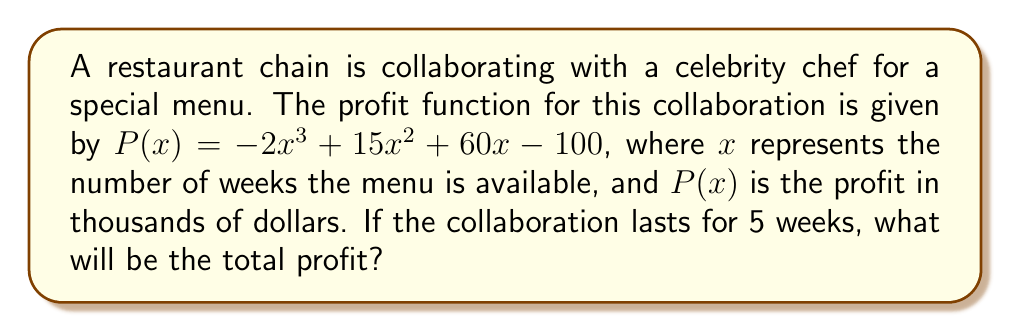Give your solution to this math problem. To find the total profit for the 5-week collaboration, we need to evaluate the profit function $P(x)$ at $x = 5$. Let's do this step by step:

1) The profit function is $P(x) = -2x^3 + 15x^2 + 60x - 100$

2) We need to calculate $P(5)$:
   $P(5) = -2(5^3) + 15(5^2) + 60(5) - 100$

3) Let's evaluate each term:
   - $-2(5^3) = -2(125) = -250$
   - $15(5^2) = 15(25) = 375$
   - $60(5) = 300$
   - $-100$ remains as is

4) Now, let's sum these values:
   $P(5) = -250 + 375 + 300 - 100 = 325$

5) Since $P(x)$ is in thousands of dollars, we multiply by 1000:
   $325 * 1000 = 325,000$

Therefore, the total profit for the 5-week collaboration will be $325,000.
Answer: $325,000 